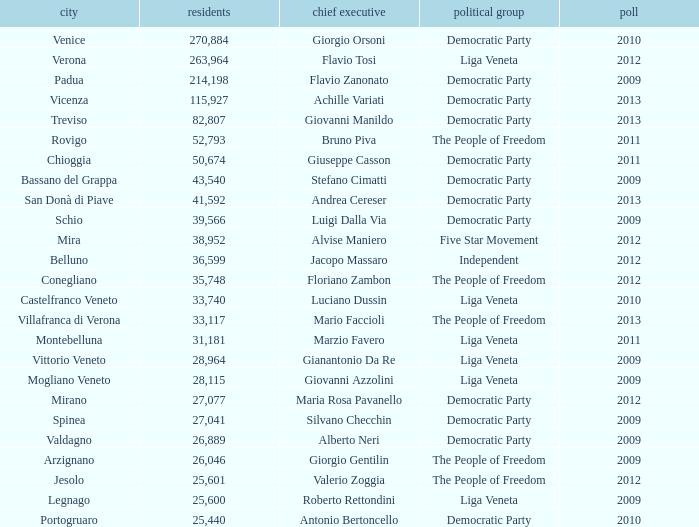How many Inhabitants were in the democratic party for an election before 2009 for Mayor of stefano cimatti? 0.0. 